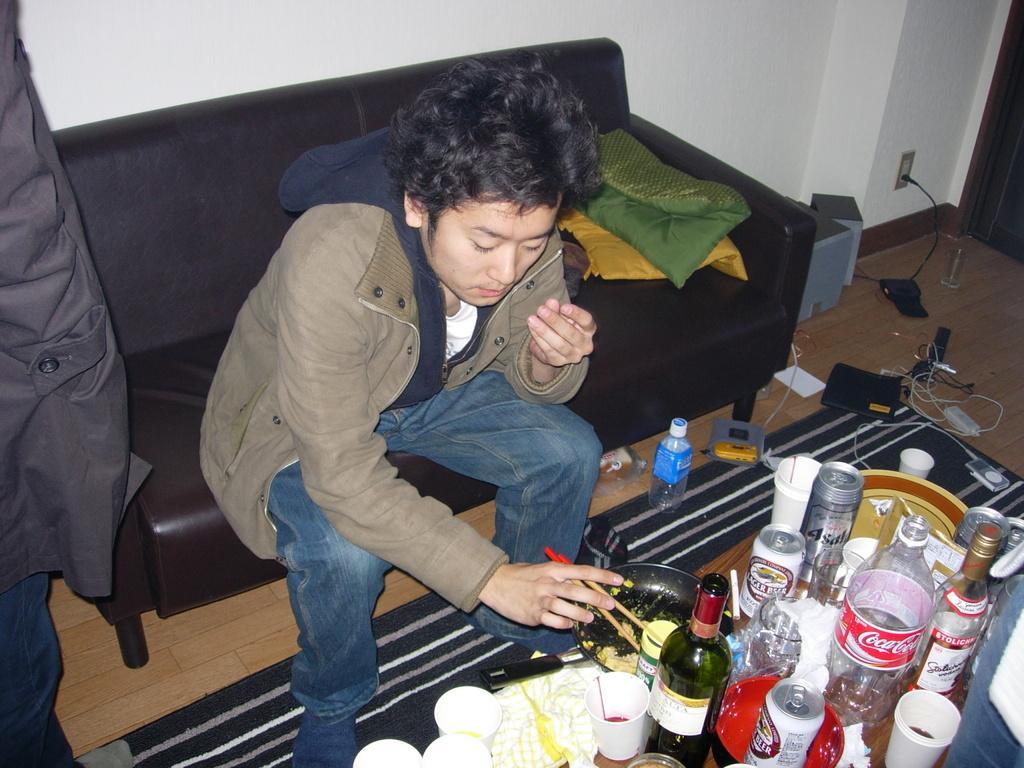Please provide a concise description of this image. In this image I see a man who is sitting on a couch, I can also see that he is holding the sticks and there is a table in front of him on which there are many cups, bottles and cans. In the background I see the wall and speakers. 